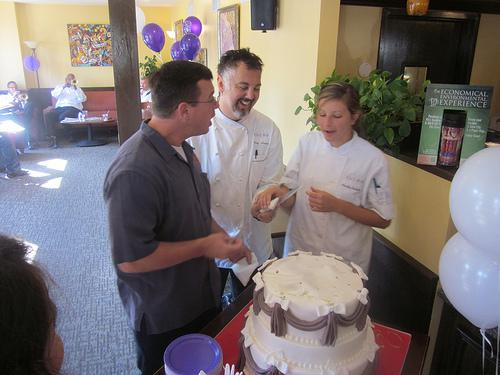Question: how do the people in the foreground appear to be?
Choices:
A. Sad.
B. Happy.
C. Ecstatic.
D. Nice.
Answer with the letter. Answer: B Question: what food item is shown in the foreground?
Choices:
A. Cake.
B. Beef.
C. Pizza.
D. Chicken.
Answer with the letter. Answer: A Question: who might the two people dressed in white in the foreground be?
Choices:
A. Doctors.
B. Nurses.
C. Medical personnel.
D. Executives.
Answer with the letter. Answer: C 